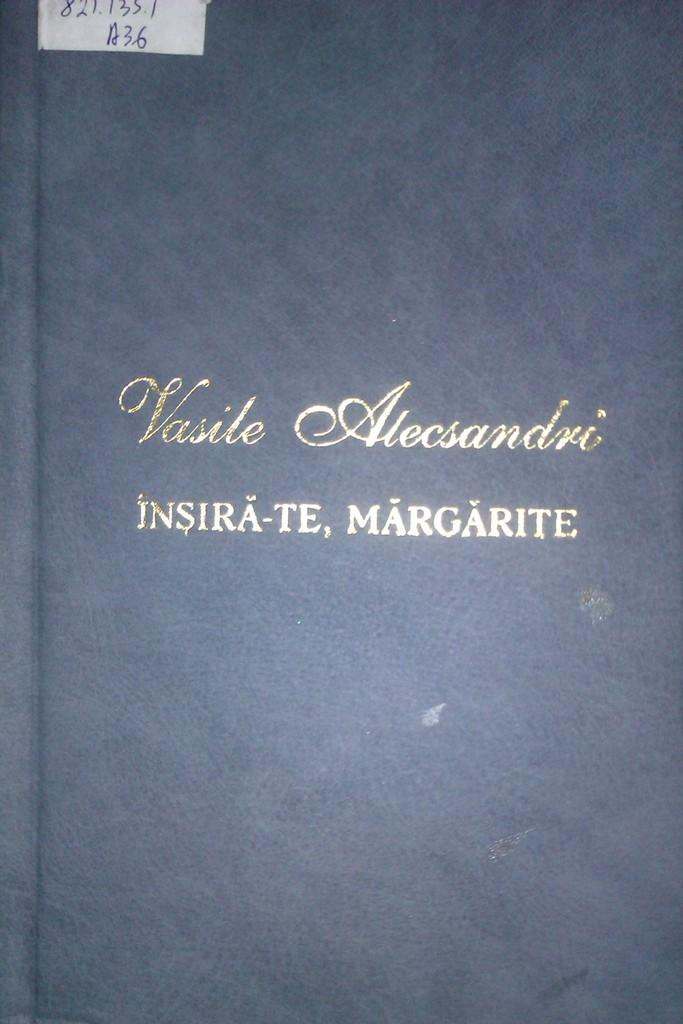<image>
Share a concise interpretation of the image provided. the word margarite is on the front of the book 